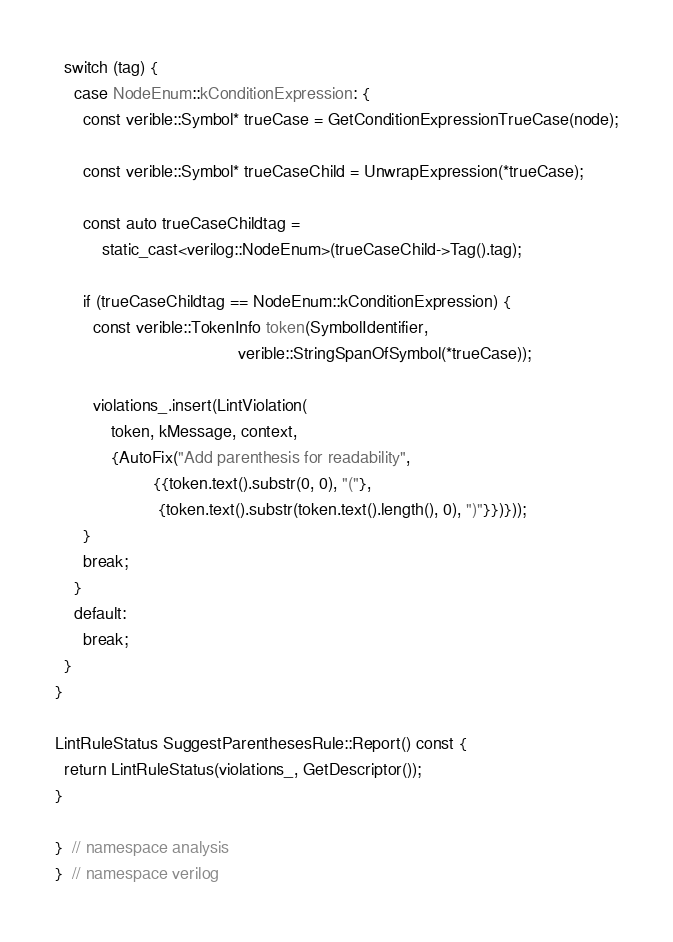Convert code to text. <code><loc_0><loc_0><loc_500><loc_500><_C++_>  switch (tag) {
    case NodeEnum::kConditionExpression: {
      const verible::Symbol* trueCase = GetConditionExpressionTrueCase(node);

      const verible::Symbol* trueCaseChild = UnwrapExpression(*trueCase);

      const auto trueCaseChildtag =
          static_cast<verilog::NodeEnum>(trueCaseChild->Tag().tag);

      if (trueCaseChildtag == NodeEnum::kConditionExpression) {
        const verible::TokenInfo token(SymbolIdentifier,
                                       verible::StringSpanOfSymbol(*trueCase));

        violations_.insert(LintViolation(
            token, kMessage, context,
            {AutoFix("Add parenthesis for readability",
                     {{token.text().substr(0, 0), "("},
                      {token.text().substr(token.text().length(), 0), ")"}})}));
      }
      break;
    }
    default:
      break;
  }
}

LintRuleStatus SuggestParenthesesRule::Report() const {
  return LintRuleStatus(violations_, GetDescriptor());
}

}  // namespace analysis
}  // namespace verilog
</code> 